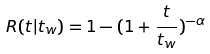<formula> <loc_0><loc_0><loc_500><loc_500>R ( t | t _ { w } ) = 1 - ( 1 + \frac { t } { t _ { w } } ) ^ { - \alpha }</formula> 